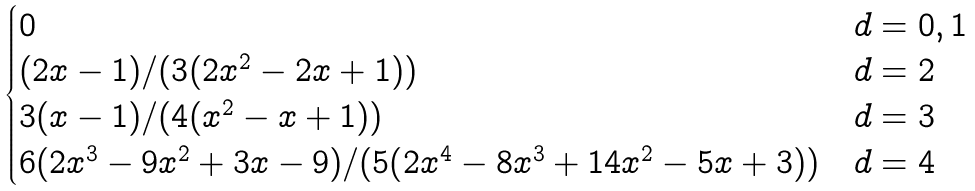<formula> <loc_0><loc_0><loc_500><loc_500>\begin{cases} 0 & d = 0 , 1 \\ ( 2 x - 1 ) / ( 3 ( 2 x ^ { 2 } - 2 x + 1 ) ) & d = 2 \\ 3 ( x - 1 ) / ( 4 ( x ^ { 2 } - x + 1 ) ) & d = 3 \\ 6 ( 2 x ^ { 3 } - 9 x ^ { 2 } + 3 x - 9 ) / ( 5 ( 2 x ^ { 4 } - 8 x ^ { 3 } + 1 4 x ^ { 2 } - 5 x + 3 ) ) & d = 4 \end{cases}</formula> 